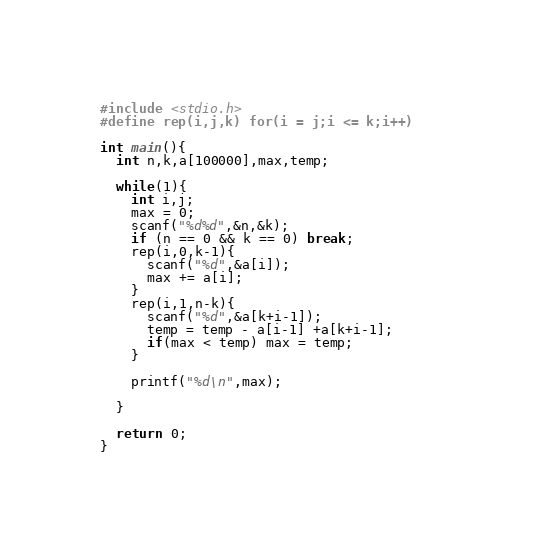<code> <loc_0><loc_0><loc_500><loc_500><_C_>#include <stdio.h>
#define rep(i,j,k) for(i = j;i <= k;i++)

int main(){
  int n,k,a[100000],max,temp;

  while(1){
    int i,j;
    max = 0;
    scanf("%d%d",&n,&k);
    if (n == 0 && k == 0) break;
    rep(i,0,k-1){
      scanf("%d",&a[i]);
      max += a[i];
    }
    rep(i,1,n-k){
      scanf("%d",&a[k+i-1]);
      temp = temp - a[i-1] +a[k+i-1];      
      if(max < temp) max = temp;
    }

    printf("%d\n",max);

  }
    
  return 0;
}</code> 